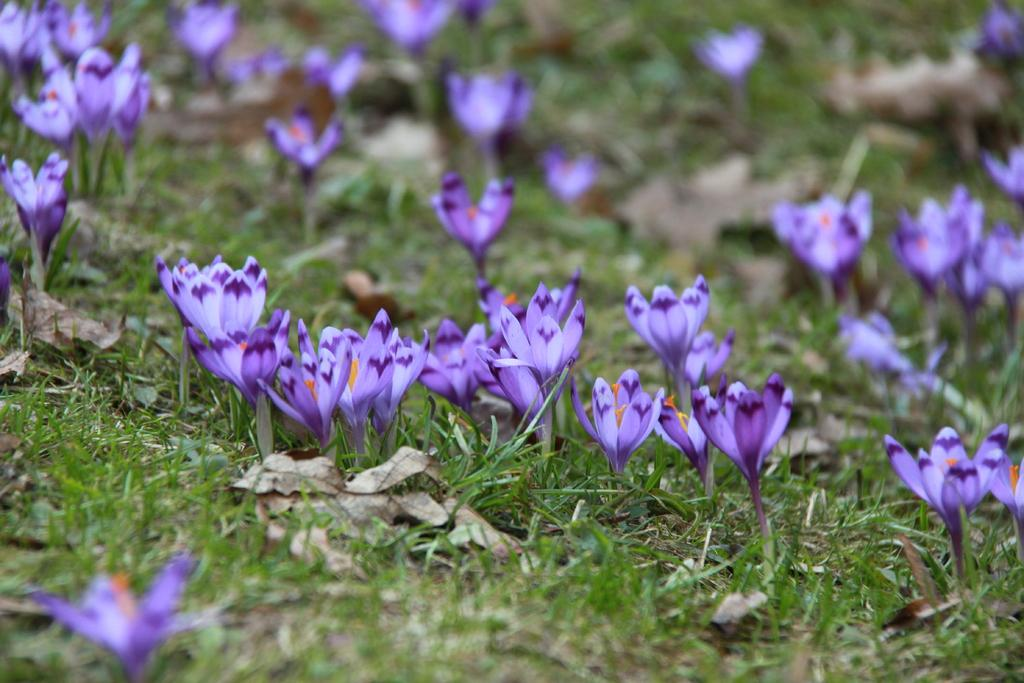What type of plants can be seen in the image? There are plants with flowers in the image. What color are the flowers on the plants? The flowers are in violet color. What can be seen in the background of the image? There is a grassland in the background of the image. What type of apparel is being worn by the zinc in the image? There is no zinc or apparel present in the image. 